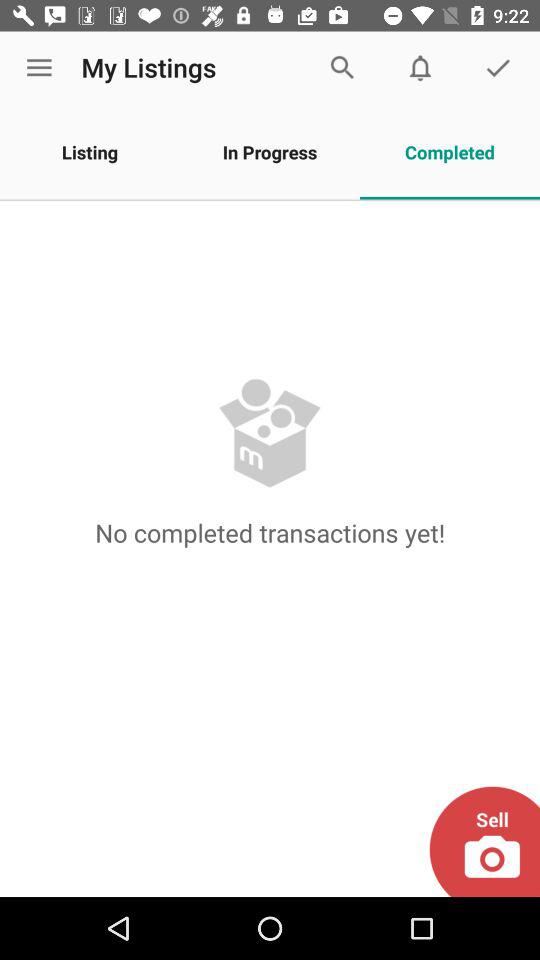Which tab is selected? The selected tab is "Completed". 